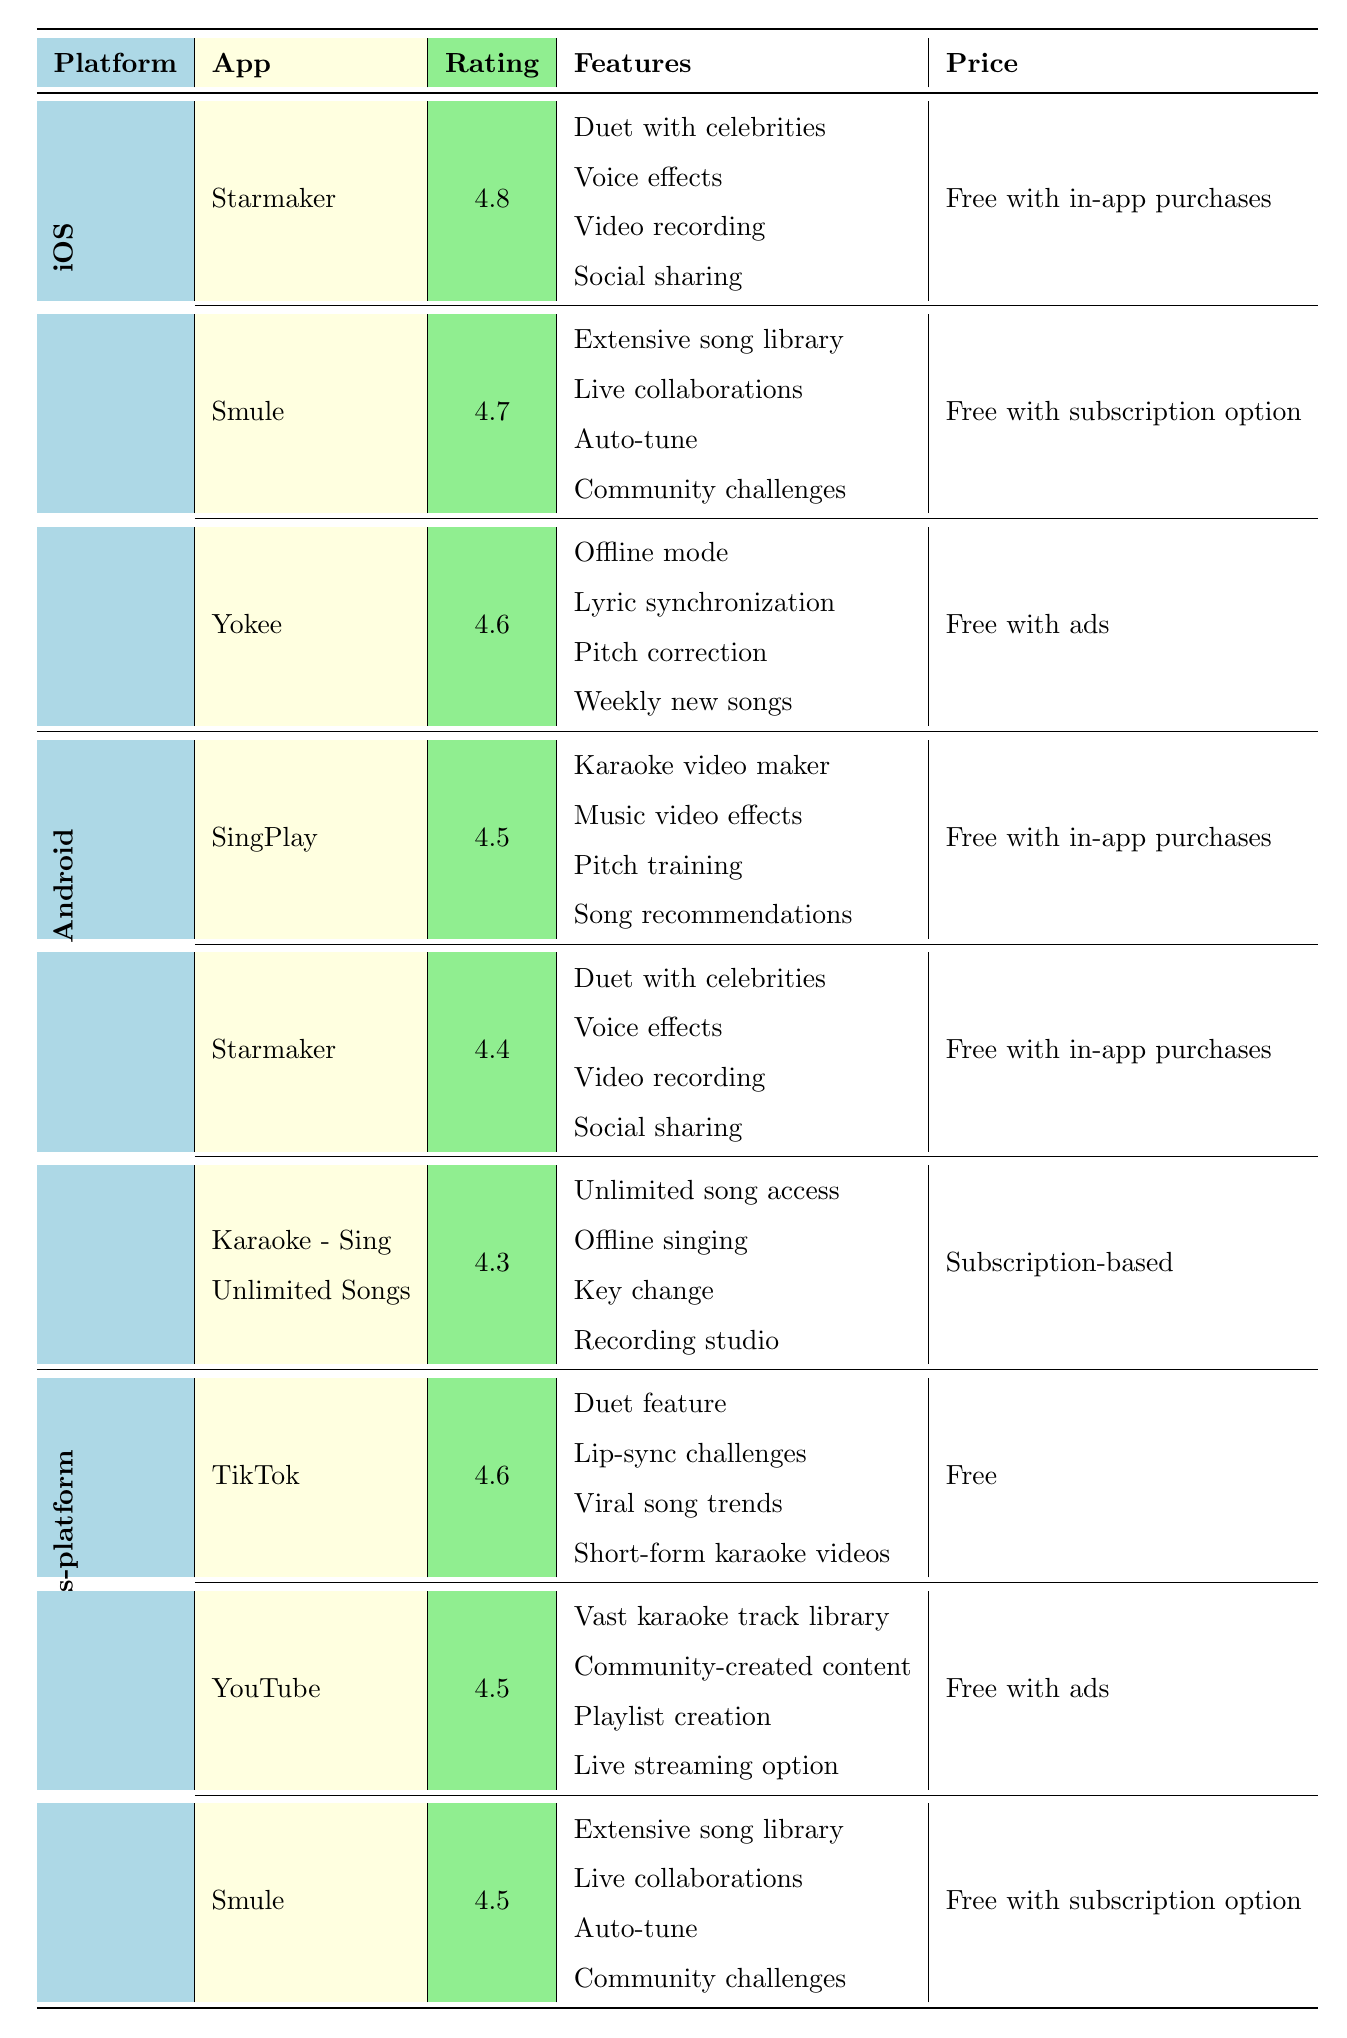What is the highest-rated karaoke app on iOS? Starmaker has the highest rating of 4.8 among the iOS apps listed in the table.
Answer: Starmaker Which karaoke app has offline mode and is available on iOS? Yokee is the only app listed under iOS that offers the offline mode feature.
Answer: Yokee How many karaoke apps are rated above 4.5 on Android? There are two apps on Android rated above 4.5: SingPlay (4.5) and Starmaker (4.4).
Answer: Two Is Smule available on both iOS and Cross-platform? Yes, Smule appears in both the iOS and Cross-platform sections of the table.
Answer: Yes What is the average rating of the karaoke apps on Android? The ratings for the Android apps are 4.5, 4.4, and 4.3. To find the average, sum them (4.5 + 4.4 + 4.3 = 13.2) and divide by 3, which gives us approximately 4.4.
Answer: 4.4 Which karaoke app offers the most features? Comparing the features listed, both Starmaker (iOS) and Smule (iOS and Cross-platform) offer four features, which is the most among the apps.
Answer: Starmaker and Smule Which platform has the lowest average rating among its karaoke apps? Android has an average rating of 4.4, while iOS has an average rating of 4.73 and Cross-platform has an average rating of 4.53. Since Android's average is the lowest, it holds this position.
Answer: Android Does every karaoke app on iOS provide a free version? Yes, all iOS apps listed (Starmaker, Smule, Yokee) are available for free, although some include in-app purchases or subscription options.
Answer: Yes Which features are shared by the karaoke apps Starmaker and Smule? Both Starmaker and Smule offer features for dueting with celebrities and live collaborations, indicating overlap in capabilities.
Answer: Duet feature and live collaborations What is the only karaoke app that is free without any ads or in-app purchases? TikTok is mentioned as a karaoke app that is free without any ads or in-app purchases, making it unique compared to others listed.
Answer: TikTok 